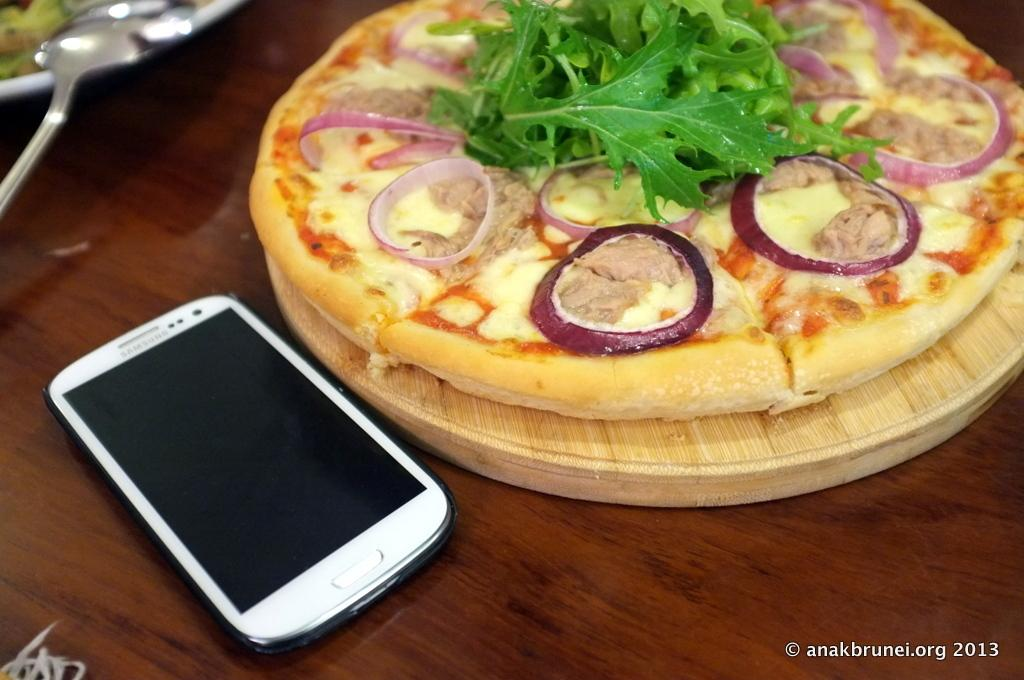What type of food is shown in the image? There is a pizza in the image. What is the pizza placed on? The pizza is on a wooden plate. What other objects can be seen in the image? There is a mobile and a spoon visible in the image. What else is on a plate in the image? There is a plate with food in the image. What type of surface is visible in the image? The wooden surface is visible in the image. What type of sign can be seen in the image? There is no sign present in the image. Is there a plantation visible in the image? There is no plantation present in the image. 